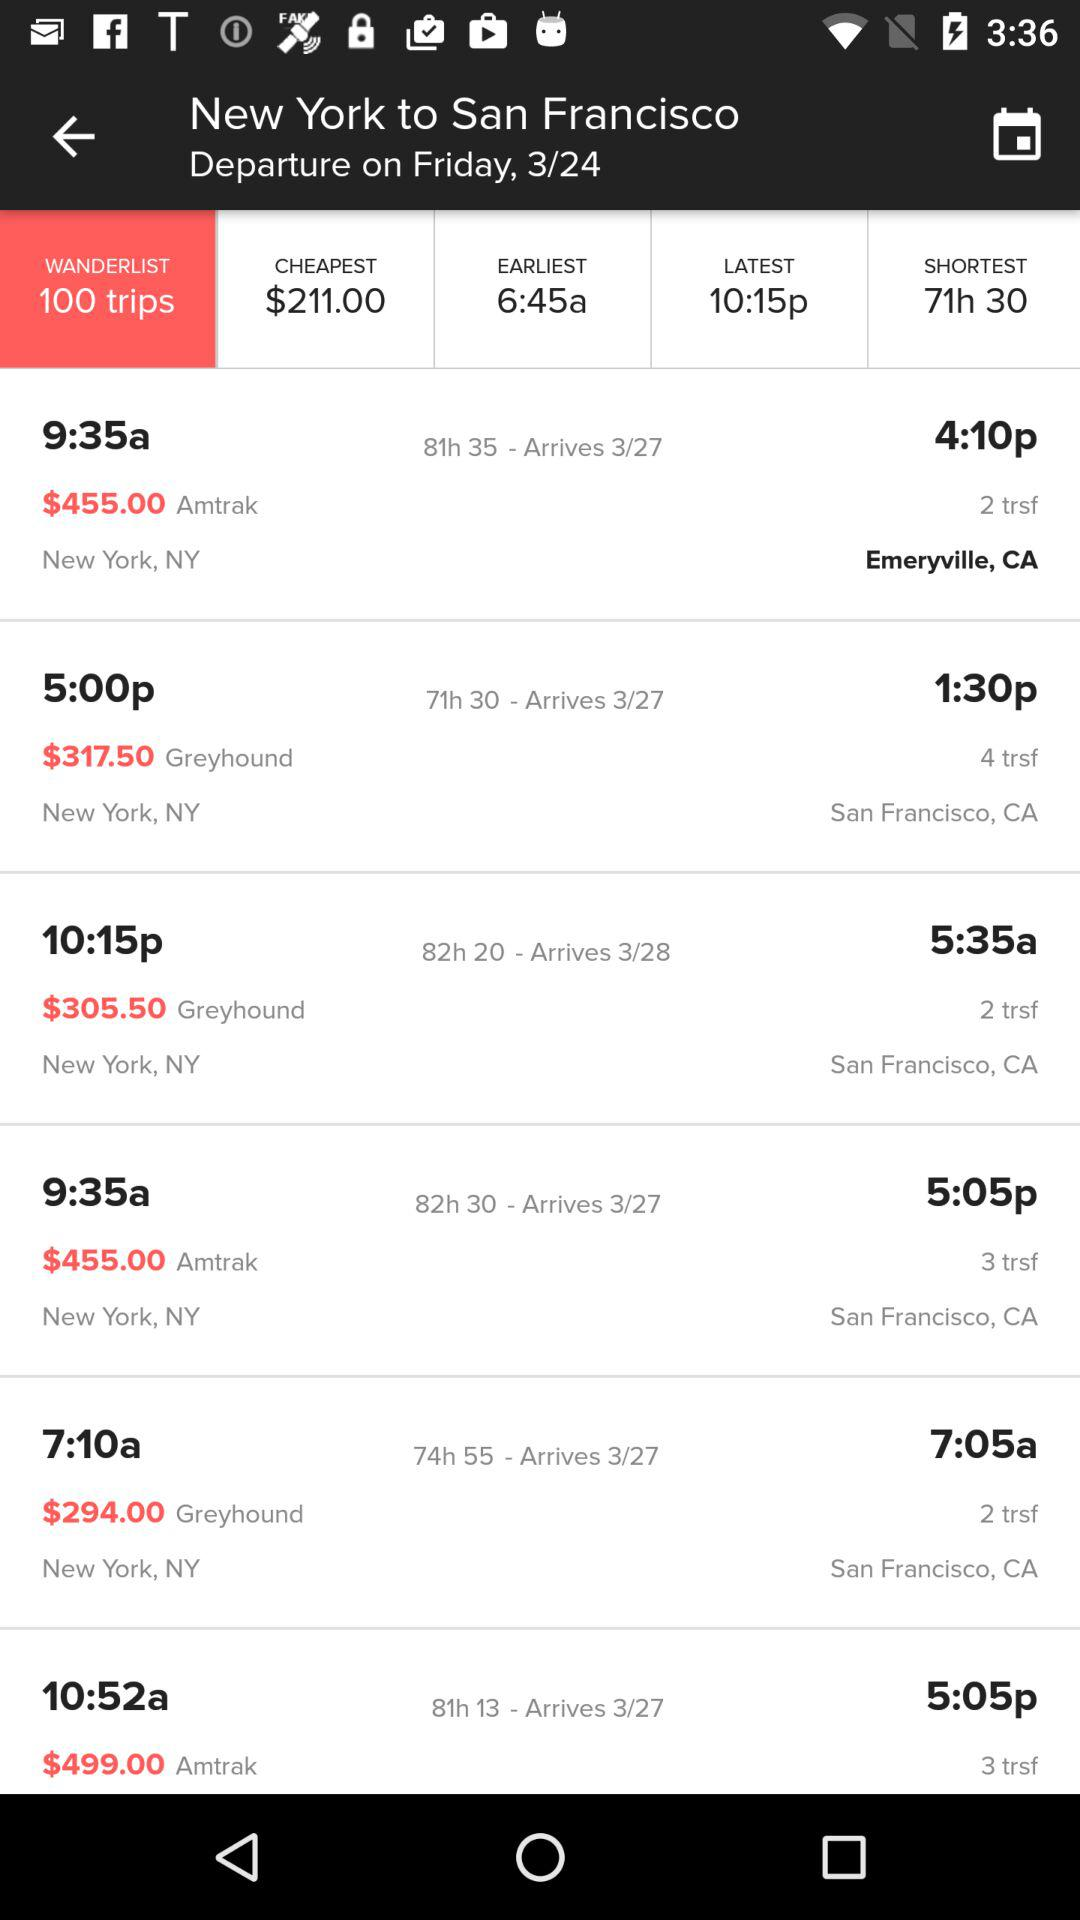What is the departure time of the flight travelling from New York to Emeryville, CA? The departure time of the flight is 9:35 a.m. 